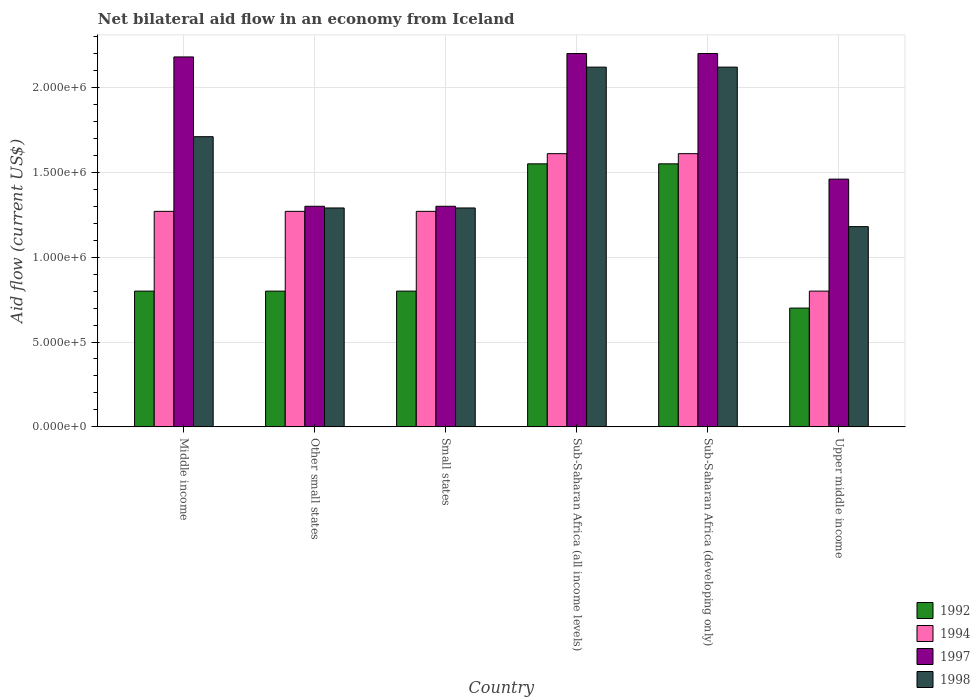How many groups of bars are there?
Provide a succinct answer. 6. How many bars are there on the 3rd tick from the left?
Keep it short and to the point. 4. How many bars are there on the 6th tick from the right?
Provide a succinct answer. 4. What is the label of the 1st group of bars from the left?
Ensure brevity in your answer.  Middle income. What is the net bilateral aid flow in 1992 in Other small states?
Give a very brief answer. 8.00e+05. Across all countries, what is the maximum net bilateral aid flow in 1994?
Your answer should be very brief. 1.61e+06. Across all countries, what is the minimum net bilateral aid flow in 1992?
Your answer should be compact. 7.00e+05. In which country was the net bilateral aid flow in 1997 maximum?
Provide a succinct answer. Sub-Saharan Africa (all income levels). In which country was the net bilateral aid flow in 1998 minimum?
Keep it short and to the point. Upper middle income. What is the total net bilateral aid flow in 1997 in the graph?
Your answer should be compact. 1.06e+07. What is the difference between the net bilateral aid flow in 1994 in Middle income and that in Upper middle income?
Provide a succinct answer. 4.70e+05. What is the difference between the net bilateral aid flow in 1994 in Sub-Saharan Africa (developing only) and the net bilateral aid flow in 1997 in Middle income?
Make the answer very short. -5.70e+05. What is the average net bilateral aid flow in 1998 per country?
Your response must be concise. 1.62e+06. What is the ratio of the net bilateral aid flow in 1998 in Middle income to that in Small states?
Offer a terse response. 1.33. Is the net bilateral aid flow in 1992 in Middle income less than that in Small states?
Keep it short and to the point. No. Is the difference between the net bilateral aid flow in 1994 in Other small states and Upper middle income greater than the difference between the net bilateral aid flow in 1998 in Other small states and Upper middle income?
Provide a short and direct response. Yes. In how many countries, is the net bilateral aid flow in 1992 greater than the average net bilateral aid flow in 1992 taken over all countries?
Give a very brief answer. 2. Is the sum of the net bilateral aid flow in 1992 in Small states and Upper middle income greater than the maximum net bilateral aid flow in 1998 across all countries?
Ensure brevity in your answer.  No. What does the 4th bar from the left in Sub-Saharan Africa (developing only) represents?
Make the answer very short. 1998. Is it the case that in every country, the sum of the net bilateral aid flow in 1992 and net bilateral aid flow in 1998 is greater than the net bilateral aid flow in 1997?
Your answer should be compact. Yes. How many legend labels are there?
Keep it short and to the point. 4. How are the legend labels stacked?
Provide a succinct answer. Vertical. What is the title of the graph?
Your answer should be compact. Net bilateral aid flow in an economy from Iceland. Does "1979" appear as one of the legend labels in the graph?
Make the answer very short. No. What is the label or title of the X-axis?
Provide a succinct answer. Country. What is the label or title of the Y-axis?
Provide a succinct answer. Aid flow (current US$). What is the Aid flow (current US$) in 1994 in Middle income?
Provide a short and direct response. 1.27e+06. What is the Aid flow (current US$) in 1997 in Middle income?
Your response must be concise. 2.18e+06. What is the Aid flow (current US$) of 1998 in Middle income?
Provide a succinct answer. 1.71e+06. What is the Aid flow (current US$) in 1994 in Other small states?
Offer a very short reply. 1.27e+06. What is the Aid flow (current US$) of 1997 in Other small states?
Provide a succinct answer. 1.30e+06. What is the Aid flow (current US$) in 1998 in Other small states?
Keep it short and to the point. 1.29e+06. What is the Aid flow (current US$) in 1994 in Small states?
Ensure brevity in your answer.  1.27e+06. What is the Aid flow (current US$) of 1997 in Small states?
Give a very brief answer. 1.30e+06. What is the Aid flow (current US$) of 1998 in Small states?
Give a very brief answer. 1.29e+06. What is the Aid flow (current US$) in 1992 in Sub-Saharan Africa (all income levels)?
Offer a very short reply. 1.55e+06. What is the Aid flow (current US$) in 1994 in Sub-Saharan Africa (all income levels)?
Provide a succinct answer. 1.61e+06. What is the Aid flow (current US$) of 1997 in Sub-Saharan Africa (all income levels)?
Your response must be concise. 2.20e+06. What is the Aid flow (current US$) of 1998 in Sub-Saharan Africa (all income levels)?
Offer a very short reply. 2.12e+06. What is the Aid flow (current US$) in 1992 in Sub-Saharan Africa (developing only)?
Ensure brevity in your answer.  1.55e+06. What is the Aid flow (current US$) in 1994 in Sub-Saharan Africa (developing only)?
Offer a very short reply. 1.61e+06. What is the Aid flow (current US$) of 1997 in Sub-Saharan Africa (developing only)?
Offer a terse response. 2.20e+06. What is the Aid flow (current US$) of 1998 in Sub-Saharan Africa (developing only)?
Make the answer very short. 2.12e+06. What is the Aid flow (current US$) in 1992 in Upper middle income?
Offer a terse response. 7.00e+05. What is the Aid flow (current US$) of 1994 in Upper middle income?
Make the answer very short. 8.00e+05. What is the Aid flow (current US$) in 1997 in Upper middle income?
Your response must be concise. 1.46e+06. What is the Aid flow (current US$) in 1998 in Upper middle income?
Provide a succinct answer. 1.18e+06. Across all countries, what is the maximum Aid flow (current US$) of 1992?
Offer a terse response. 1.55e+06. Across all countries, what is the maximum Aid flow (current US$) in 1994?
Make the answer very short. 1.61e+06. Across all countries, what is the maximum Aid flow (current US$) of 1997?
Make the answer very short. 2.20e+06. Across all countries, what is the maximum Aid flow (current US$) of 1998?
Make the answer very short. 2.12e+06. Across all countries, what is the minimum Aid flow (current US$) of 1997?
Your response must be concise. 1.30e+06. Across all countries, what is the minimum Aid flow (current US$) in 1998?
Make the answer very short. 1.18e+06. What is the total Aid flow (current US$) in 1992 in the graph?
Give a very brief answer. 6.20e+06. What is the total Aid flow (current US$) in 1994 in the graph?
Ensure brevity in your answer.  7.83e+06. What is the total Aid flow (current US$) in 1997 in the graph?
Your answer should be compact. 1.06e+07. What is the total Aid flow (current US$) in 1998 in the graph?
Provide a short and direct response. 9.71e+06. What is the difference between the Aid flow (current US$) of 1992 in Middle income and that in Other small states?
Give a very brief answer. 0. What is the difference between the Aid flow (current US$) of 1994 in Middle income and that in Other small states?
Your answer should be very brief. 0. What is the difference between the Aid flow (current US$) in 1997 in Middle income and that in Other small states?
Your response must be concise. 8.80e+05. What is the difference between the Aid flow (current US$) in 1992 in Middle income and that in Small states?
Offer a very short reply. 0. What is the difference between the Aid flow (current US$) of 1994 in Middle income and that in Small states?
Keep it short and to the point. 0. What is the difference between the Aid flow (current US$) in 1997 in Middle income and that in Small states?
Provide a short and direct response. 8.80e+05. What is the difference between the Aid flow (current US$) in 1992 in Middle income and that in Sub-Saharan Africa (all income levels)?
Keep it short and to the point. -7.50e+05. What is the difference between the Aid flow (current US$) of 1994 in Middle income and that in Sub-Saharan Africa (all income levels)?
Offer a very short reply. -3.40e+05. What is the difference between the Aid flow (current US$) of 1997 in Middle income and that in Sub-Saharan Africa (all income levels)?
Your answer should be compact. -2.00e+04. What is the difference between the Aid flow (current US$) in 1998 in Middle income and that in Sub-Saharan Africa (all income levels)?
Your response must be concise. -4.10e+05. What is the difference between the Aid flow (current US$) in 1992 in Middle income and that in Sub-Saharan Africa (developing only)?
Provide a succinct answer. -7.50e+05. What is the difference between the Aid flow (current US$) in 1994 in Middle income and that in Sub-Saharan Africa (developing only)?
Offer a terse response. -3.40e+05. What is the difference between the Aid flow (current US$) in 1998 in Middle income and that in Sub-Saharan Africa (developing only)?
Your response must be concise. -4.10e+05. What is the difference between the Aid flow (current US$) of 1994 in Middle income and that in Upper middle income?
Ensure brevity in your answer.  4.70e+05. What is the difference between the Aid flow (current US$) of 1997 in Middle income and that in Upper middle income?
Provide a short and direct response. 7.20e+05. What is the difference between the Aid flow (current US$) of 1998 in Middle income and that in Upper middle income?
Offer a terse response. 5.30e+05. What is the difference between the Aid flow (current US$) of 1992 in Other small states and that in Small states?
Offer a terse response. 0. What is the difference between the Aid flow (current US$) in 1997 in Other small states and that in Small states?
Ensure brevity in your answer.  0. What is the difference between the Aid flow (current US$) in 1992 in Other small states and that in Sub-Saharan Africa (all income levels)?
Provide a succinct answer. -7.50e+05. What is the difference between the Aid flow (current US$) of 1994 in Other small states and that in Sub-Saharan Africa (all income levels)?
Offer a terse response. -3.40e+05. What is the difference between the Aid flow (current US$) of 1997 in Other small states and that in Sub-Saharan Africa (all income levels)?
Your answer should be compact. -9.00e+05. What is the difference between the Aid flow (current US$) of 1998 in Other small states and that in Sub-Saharan Africa (all income levels)?
Provide a succinct answer. -8.30e+05. What is the difference between the Aid flow (current US$) in 1992 in Other small states and that in Sub-Saharan Africa (developing only)?
Keep it short and to the point. -7.50e+05. What is the difference between the Aid flow (current US$) of 1997 in Other small states and that in Sub-Saharan Africa (developing only)?
Offer a very short reply. -9.00e+05. What is the difference between the Aid flow (current US$) in 1998 in Other small states and that in Sub-Saharan Africa (developing only)?
Ensure brevity in your answer.  -8.30e+05. What is the difference between the Aid flow (current US$) in 1992 in Other small states and that in Upper middle income?
Ensure brevity in your answer.  1.00e+05. What is the difference between the Aid flow (current US$) of 1994 in Other small states and that in Upper middle income?
Your answer should be very brief. 4.70e+05. What is the difference between the Aid flow (current US$) of 1998 in Other small states and that in Upper middle income?
Offer a terse response. 1.10e+05. What is the difference between the Aid flow (current US$) in 1992 in Small states and that in Sub-Saharan Africa (all income levels)?
Ensure brevity in your answer.  -7.50e+05. What is the difference between the Aid flow (current US$) of 1997 in Small states and that in Sub-Saharan Africa (all income levels)?
Your answer should be very brief. -9.00e+05. What is the difference between the Aid flow (current US$) in 1998 in Small states and that in Sub-Saharan Africa (all income levels)?
Provide a short and direct response. -8.30e+05. What is the difference between the Aid flow (current US$) in 1992 in Small states and that in Sub-Saharan Africa (developing only)?
Offer a very short reply. -7.50e+05. What is the difference between the Aid flow (current US$) of 1994 in Small states and that in Sub-Saharan Africa (developing only)?
Offer a terse response. -3.40e+05. What is the difference between the Aid flow (current US$) in 1997 in Small states and that in Sub-Saharan Africa (developing only)?
Make the answer very short. -9.00e+05. What is the difference between the Aid flow (current US$) of 1998 in Small states and that in Sub-Saharan Africa (developing only)?
Offer a terse response. -8.30e+05. What is the difference between the Aid flow (current US$) of 1992 in Small states and that in Upper middle income?
Your answer should be compact. 1.00e+05. What is the difference between the Aid flow (current US$) of 1992 in Sub-Saharan Africa (all income levels) and that in Sub-Saharan Africa (developing only)?
Offer a very short reply. 0. What is the difference between the Aid flow (current US$) in 1992 in Sub-Saharan Africa (all income levels) and that in Upper middle income?
Ensure brevity in your answer.  8.50e+05. What is the difference between the Aid flow (current US$) of 1994 in Sub-Saharan Africa (all income levels) and that in Upper middle income?
Ensure brevity in your answer.  8.10e+05. What is the difference between the Aid flow (current US$) in 1997 in Sub-Saharan Africa (all income levels) and that in Upper middle income?
Provide a succinct answer. 7.40e+05. What is the difference between the Aid flow (current US$) in 1998 in Sub-Saharan Africa (all income levels) and that in Upper middle income?
Offer a very short reply. 9.40e+05. What is the difference between the Aid flow (current US$) in 1992 in Sub-Saharan Africa (developing only) and that in Upper middle income?
Provide a short and direct response. 8.50e+05. What is the difference between the Aid flow (current US$) of 1994 in Sub-Saharan Africa (developing only) and that in Upper middle income?
Keep it short and to the point. 8.10e+05. What is the difference between the Aid flow (current US$) in 1997 in Sub-Saharan Africa (developing only) and that in Upper middle income?
Give a very brief answer. 7.40e+05. What is the difference between the Aid flow (current US$) in 1998 in Sub-Saharan Africa (developing only) and that in Upper middle income?
Your answer should be compact. 9.40e+05. What is the difference between the Aid flow (current US$) in 1992 in Middle income and the Aid flow (current US$) in 1994 in Other small states?
Your answer should be compact. -4.70e+05. What is the difference between the Aid flow (current US$) of 1992 in Middle income and the Aid flow (current US$) of 1997 in Other small states?
Your answer should be very brief. -5.00e+05. What is the difference between the Aid flow (current US$) of 1992 in Middle income and the Aid flow (current US$) of 1998 in Other small states?
Give a very brief answer. -4.90e+05. What is the difference between the Aid flow (current US$) of 1994 in Middle income and the Aid flow (current US$) of 1997 in Other small states?
Your answer should be compact. -3.00e+04. What is the difference between the Aid flow (current US$) of 1997 in Middle income and the Aid flow (current US$) of 1998 in Other small states?
Ensure brevity in your answer.  8.90e+05. What is the difference between the Aid flow (current US$) of 1992 in Middle income and the Aid flow (current US$) of 1994 in Small states?
Your answer should be very brief. -4.70e+05. What is the difference between the Aid flow (current US$) in 1992 in Middle income and the Aid flow (current US$) in 1997 in Small states?
Your answer should be compact. -5.00e+05. What is the difference between the Aid flow (current US$) in 1992 in Middle income and the Aid flow (current US$) in 1998 in Small states?
Your answer should be compact. -4.90e+05. What is the difference between the Aid flow (current US$) of 1994 in Middle income and the Aid flow (current US$) of 1997 in Small states?
Ensure brevity in your answer.  -3.00e+04. What is the difference between the Aid flow (current US$) of 1997 in Middle income and the Aid flow (current US$) of 1998 in Small states?
Your answer should be very brief. 8.90e+05. What is the difference between the Aid flow (current US$) in 1992 in Middle income and the Aid flow (current US$) in 1994 in Sub-Saharan Africa (all income levels)?
Your answer should be compact. -8.10e+05. What is the difference between the Aid flow (current US$) of 1992 in Middle income and the Aid flow (current US$) of 1997 in Sub-Saharan Africa (all income levels)?
Offer a very short reply. -1.40e+06. What is the difference between the Aid flow (current US$) in 1992 in Middle income and the Aid flow (current US$) in 1998 in Sub-Saharan Africa (all income levels)?
Keep it short and to the point. -1.32e+06. What is the difference between the Aid flow (current US$) of 1994 in Middle income and the Aid flow (current US$) of 1997 in Sub-Saharan Africa (all income levels)?
Your response must be concise. -9.30e+05. What is the difference between the Aid flow (current US$) of 1994 in Middle income and the Aid flow (current US$) of 1998 in Sub-Saharan Africa (all income levels)?
Give a very brief answer. -8.50e+05. What is the difference between the Aid flow (current US$) in 1992 in Middle income and the Aid flow (current US$) in 1994 in Sub-Saharan Africa (developing only)?
Your answer should be very brief. -8.10e+05. What is the difference between the Aid flow (current US$) in 1992 in Middle income and the Aid flow (current US$) in 1997 in Sub-Saharan Africa (developing only)?
Your response must be concise. -1.40e+06. What is the difference between the Aid flow (current US$) in 1992 in Middle income and the Aid flow (current US$) in 1998 in Sub-Saharan Africa (developing only)?
Offer a very short reply. -1.32e+06. What is the difference between the Aid flow (current US$) in 1994 in Middle income and the Aid flow (current US$) in 1997 in Sub-Saharan Africa (developing only)?
Keep it short and to the point. -9.30e+05. What is the difference between the Aid flow (current US$) of 1994 in Middle income and the Aid flow (current US$) of 1998 in Sub-Saharan Africa (developing only)?
Offer a terse response. -8.50e+05. What is the difference between the Aid flow (current US$) in 1992 in Middle income and the Aid flow (current US$) in 1997 in Upper middle income?
Ensure brevity in your answer.  -6.60e+05. What is the difference between the Aid flow (current US$) of 1992 in Middle income and the Aid flow (current US$) of 1998 in Upper middle income?
Your response must be concise. -3.80e+05. What is the difference between the Aid flow (current US$) in 1994 in Middle income and the Aid flow (current US$) in 1997 in Upper middle income?
Your response must be concise. -1.90e+05. What is the difference between the Aid flow (current US$) in 1992 in Other small states and the Aid flow (current US$) in 1994 in Small states?
Make the answer very short. -4.70e+05. What is the difference between the Aid flow (current US$) of 1992 in Other small states and the Aid flow (current US$) of 1997 in Small states?
Offer a terse response. -5.00e+05. What is the difference between the Aid flow (current US$) in 1992 in Other small states and the Aid flow (current US$) in 1998 in Small states?
Give a very brief answer. -4.90e+05. What is the difference between the Aid flow (current US$) of 1997 in Other small states and the Aid flow (current US$) of 1998 in Small states?
Your answer should be compact. 10000. What is the difference between the Aid flow (current US$) of 1992 in Other small states and the Aid flow (current US$) of 1994 in Sub-Saharan Africa (all income levels)?
Your response must be concise. -8.10e+05. What is the difference between the Aid flow (current US$) of 1992 in Other small states and the Aid flow (current US$) of 1997 in Sub-Saharan Africa (all income levels)?
Your answer should be compact. -1.40e+06. What is the difference between the Aid flow (current US$) of 1992 in Other small states and the Aid flow (current US$) of 1998 in Sub-Saharan Africa (all income levels)?
Offer a terse response. -1.32e+06. What is the difference between the Aid flow (current US$) of 1994 in Other small states and the Aid flow (current US$) of 1997 in Sub-Saharan Africa (all income levels)?
Offer a very short reply. -9.30e+05. What is the difference between the Aid flow (current US$) in 1994 in Other small states and the Aid flow (current US$) in 1998 in Sub-Saharan Africa (all income levels)?
Offer a terse response. -8.50e+05. What is the difference between the Aid flow (current US$) of 1997 in Other small states and the Aid flow (current US$) of 1998 in Sub-Saharan Africa (all income levels)?
Provide a succinct answer. -8.20e+05. What is the difference between the Aid flow (current US$) of 1992 in Other small states and the Aid flow (current US$) of 1994 in Sub-Saharan Africa (developing only)?
Give a very brief answer. -8.10e+05. What is the difference between the Aid flow (current US$) in 1992 in Other small states and the Aid flow (current US$) in 1997 in Sub-Saharan Africa (developing only)?
Your response must be concise. -1.40e+06. What is the difference between the Aid flow (current US$) in 1992 in Other small states and the Aid flow (current US$) in 1998 in Sub-Saharan Africa (developing only)?
Keep it short and to the point. -1.32e+06. What is the difference between the Aid flow (current US$) in 1994 in Other small states and the Aid flow (current US$) in 1997 in Sub-Saharan Africa (developing only)?
Your answer should be compact. -9.30e+05. What is the difference between the Aid flow (current US$) of 1994 in Other small states and the Aid flow (current US$) of 1998 in Sub-Saharan Africa (developing only)?
Provide a short and direct response. -8.50e+05. What is the difference between the Aid flow (current US$) of 1997 in Other small states and the Aid flow (current US$) of 1998 in Sub-Saharan Africa (developing only)?
Make the answer very short. -8.20e+05. What is the difference between the Aid flow (current US$) of 1992 in Other small states and the Aid flow (current US$) of 1994 in Upper middle income?
Offer a very short reply. 0. What is the difference between the Aid flow (current US$) in 1992 in Other small states and the Aid flow (current US$) in 1997 in Upper middle income?
Provide a short and direct response. -6.60e+05. What is the difference between the Aid flow (current US$) in 1992 in Other small states and the Aid flow (current US$) in 1998 in Upper middle income?
Give a very brief answer. -3.80e+05. What is the difference between the Aid flow (current US$) of 1994 in Other small states and the Aid flow (current US$) of 1998 in Upper middle income?
Provide a succinct answer. 9.00e+04. What is the difference between the Aid flow (current US$) of 1997 in Other small states and the Aid flow (current US$) of 1998 in Upper middle income?
Keep it short and to the point. 1.20e+05. What is the difference between the Aid flow (current US$) of 1992 in Small states and the Aid flow (current US$) of 1994 in Sub-Saharan Africa (all income levels)?
Keep it short and to the point. -8.10e+05. What is the difference between the Aid flow (current US$) of 1992 in Small states and the Aid flow (current US$) of 1997 in Sub-Saharan Africa (all income levels)?
Provide a succinct answer. -1.40e+06. What is the difference between the Aid flow (current US$) in 1992 in Small states and the Aid flow (current US$) in 1998 in Sub-Saharan Africa (all income levels)?
Your answer should be compact. -1.32e+06. What is the difference between the Aid flow (current US$) in 1994 in Small states and the Aid flow (current US$) in 1997 in Sub-Saharan Africa (all income levels)?
Make the answer very short. -9.30e+05. What is the difference between the Aid flow (current US$) of 1994 in Small states and the Aid flow (current US$) of 1998 in Sub-Saharan Africa (all income levels)?
Your answer should be compact. -8.50e+05. What is the difference between the Aid flow (current US$) of 1997 in Small states and the Aid flow (current US$) of 1998 in Sub-Saharan Africa (all income levels)?
Offer a very short reply. -8.20e+05. What is the difference between the Aid flow (current US$) in 1992 in Small states and the Aid flow (current US$) in 1994 in Sub-Saharan Africa (developing only)?
Your answer should be very brief. -8.10e+05. What is the difference between the Aid flow (current US$) in 1992 in Small states and the Aid flow (current US$) in 1997 in Sub-Saharan Africa (developing only)?
Make the answer very short. -1.40e+06. What is the difference between the Aid flow (current US$) in 1992 in Small states and the Aid flow (current US$) in 1998 in Sub-Saharan Africa (developing only)?
Your answer should be very brief. -1.32e+06. What is the difference between the Aid flow (current US$) of 1994 in Small states and the Aid flow (current US$) of 1997 in Sub-Saharan Africa (developing only)?
Offer a terse response. -9.30e+05. What is the difference between the Aid flow (current US$) of 1994 in Small states and the Aid flow (current US$) of 1998 in Sub-Saharan Africa (developing only)?
Offer a very short reply. -8.50e+05. What is the difference between the Aid flow (current US$) in 1997 in Small states and the Aid flow (current US$) in 1998 in Sub-Saharan Africa (developing only)?
Give a very brief answer. -8.20e+05. What is the difference between the Aid flow (current US$) of 1992 in Small states and the Aid flow (current US$) of 1994 in Upper middle income?
Provide a succinct answer. 0. What is the difference between the Aid flow (current US$) of 1992 in Small states and the Aid flow (current US$) of 1997 in Upper middle income?
Ensure brevity in your answer.  -6.60e+05. What is the difference between the Aid flow (current US$) of 1992 in Small states and the Aid flow (current US$) of 1998 in Upper middle income?
Make the answer very short. -3.80e+05. What is the difference between the Aid flow (current US$) of 1994 in Small states and the Aid flow (current US$) of 1997 in Upper middle income?
Your answer should be very brief. -1.90e+05. What is the difference between the Aid flow (current US$) of 1994 in Small states and the Aid flow (current US$) of 1998 in Upper middle income?
Keep it short and to the point. 9.00e+04. What is the difference between the Aid flow (current US$) in 1992 in Sub-Saharan Africa (all income levels) and the Aid flow (current US$) in 1997 in Sub-Saharan Africa (developing only)?
Your response must be concise. -6.50e+05. What is the difference between the Aid flow (current US$) in 1992 in Sub-Saharan Africa (all income levels) and the Aid flow (current US$) in 1998 in Sub-Saharan Africa (developing only)?
Make the answer very short. -5.70e+05. What is the difference between the Aid flow (current US$) of 1994 in Sub-Saharan Africa (all income levels) and the Aid flow (current US$) of 1997 in Sub-Saharan Africa (developing only)?
Provide a short and direct response. -5.90e+05. What is the difference between the Aid flow (current US$) of 1994 in Sub-Saharan Africa (all income levels) and the Aid flow (current US$) of 1998 in Sub-Saharan Africa (developing only)?
Your answer should be very brief. -5.10e+05. What is the difference between the Aid flow (current US$) in 1997 in Sub-Saharan Africa (all income levels) and the Aid flow (current US$) in 1998 in Sub-Saharan Africa (developing only)?
Provide a succinct answer. 8.00e+04. What is the difference between the Aid flow (current US$) in 1992 in Sub-Saharan Africa (all income levels) and the Aid flow (current US$) in 1994 in Upper middle income?
Provide a short and direct response. 7.50e+05. What is the difference between the Aid flow (current US$) in 1997 in Sub-Saharan Africa (all income levels) and the Aid flow (current US$) in 1998 in Upper middle income?
Provide a short and direct response. 1.02e+06. What is the difference between the Aid flow (current US$) of 1992 in Sub-Saharan Africa (developing only) and the Aid flow (current US$) of 1994 in Upper middle income?
Ensure brevity in your answer.  7.50e+05. What is the difference between the Aid flow (current US$) in 1992 in Sub-Saharan Africa (developing only) and the Aid flow (current US$) in 1997 in Upper middle income?
Give a very brief answer. 9.00e+04. What is the difference between the Aid flow (current US$) in 1994 in Sub-Saharan Africa (developing only) and the Aid flow (current US$) in 1997 in Upper middle income?
Your answer should be very brief. 1.50e+05. What is the difference between the Aid flow (current US$) in 1997 in Sub-Saharan Africa (developing only) and the Aid flow (current US$) in 1998 in Upper middle income?
Keep it short and to the point. 1.02e+06. What is the average Aid flow (current US$) in 1992 per country?
Keep it short and to the point. 1.03e+06. What is the average Aid flow (current US$) of 1994 per country?
Offer a very short reply. 1.30e+06. What is the average Aid flow (current US$) in 1997 per country?
Ensure brevity in your answer.  1.77e+06. What is the average Aid flow (current US$) of 1998 per country?
Keep it short and to the point. 1.62e+06. What is the difference between the Aid flow (current US$) of 1992 and Aid flow (current US$) of 1994 in Middle income?
Give a very brief answer. -4.70e+05. What is the difference between the Aid flow (current US$) in 1992 and Aid flow (current US$) in 1997 in Middle income?
Make the answer very short. -1.38e+06. What is the difference between the Aid flow (current US$) in 1992 and Aid flow (current US$) in 1998 in Middle income?
Give a very brief answer. -9.10e+05. What is the difference between the Aid flow (current US$) of 1994 and Aid flow (current US$) of 1997 in Middle income?
Provide a succinct answer. -9.10e+05. What is the difference between the Aid flow (current US$) of 1994 and Aid flow (current US$) of 1998 in Middle income?
Ensure brevity in your answer.  -4.40e+05. What is the difference between the Aid flow (current US$) of 1992 and Aid flow (current US$) of 1994 in Other small states?
Offer a terse response. -4.70e+05. What is the difference between the Aid flow (current US$) of 1992 and Aid flow (current US$) of 1997 in Other small states?
Offer a terse response. -5.00e+05. What is the difference between the Aid flow (current US$) in 1992 and Aid flow (current US$) in 1998 in Other small states?
Ensure brevity in your answer.  -4.90e+05. What is the difference between the Aid flow (current US$) in 1994 and Aid flow (current US$) in 1997 in Other small states?
Offer a terse response. -3.00e+04. What is the difference between the Aid flow (current US$) of 1992 and Aid flow (current US$) of 1994 in Small states?
Offer a very short reply. -4.70e+05. What is the difference between the Aid flow (current US$) of 1992 and Aid flow (current US$) of 1997 in Small states?
Keep it short and to the point. -5.00e+05. What is the difference between the Aid flow (current US$) of 1992 and Aid flow (current US$) of 1998 in Small states?
Make the answer very short. -4.90e+05. What is the difference between the Aid flow (current US$) of 1994 and Aid flow (current US$) of 1997 in Small states?
Provide a succinct answer. -3.00e+04. What is the difference between the Aid flow (current US$) of 1994 and Aid flow (current US$) of 1998 in Small states?
Keep it short and to the point. -2.00e+04. What is the difference between the Aid flow (current US$) in 1997 and Aid flow (current US$) in 1998 in Small states?
Keep it short and to the point. 10000. What is the difference between the Aid flow (current US$) in 1992 and Aid flow (current US$) in 1997 in Sub-Saharan Africa (all income levels)?
Make the answer very short. -6.50e+05. What is the difference between the Aid flow (current US$) of 1992 and Aid flow (current US$) of 1998 in Sub-Saharan Africa (all income levels)?
Your answer should be very brief. -5.70e+05. What is the difference between the Aid flow (current US$) in 1994 and Aid flow (current US$) in 1997 in Sub-Saharan Africa (all income levels)?
Make the answer very short. -5.90e+05. What is the difference between the Aid flow (current US$) of 1994 and Aid flow (current US$) of 1998 in Sub-Saharan Africa (all income levels)?
Ensure brevity in your answer.  -5.10e+05. What is the difference between the Aid flow (current US$) of 1992 and Aid flow (current US$) of 1997 in Sub-Saharan Africa (developing only)?
Your response must be concise. -6.50e+05. What is the difference between the Aid flow (current US$) of 1992 and Aid flow (current US$) of 1998 in Sub-Saharan Africa (developing only)?
Give a very brief answer. -5.70e+05. What is the difference between the Aid flow (current US$) of 1994 and Aid flow (current US$) of 1997 in Sub-Saharan Africa (developing only)?
Keep it short and to the point. -5.90e+05. What is the difference between the Aid flow (current US$) in 1994 and Aid flow (current US$) in 1998 in Sub-Saharan Africa (developing only)?
Provide a short and direct response. -5.10e+05. What is the difference between the Aid flow (current US$) in 1997 and Aid flow (current US$) in 1998 in Sub-Saharan Africa (developing only)?
Make the answer very short. 8.00e+04. What is the difference between the Aid flow (current US$) in 1992 and Aid flow (current US$) in 1997 in Upper middle income?
Give a very brief answer. -7.60e+05. What is the difference between the Aid flow (current US$) in 1992 and Aid flow (current US$) in 1998 in Upper middle income?
Your response must be concise. -4.80e+05. What is the difference between the Aid flow (current US$) in 1994 and Aid flow (current US$) in 1997 in Upper middle income?
Provide a short and direct response. -6.60e+05. What is the difference between the Aid flow (current US$) of 1994 and Aid flow (current US$) of 1998 in Upper middle income?
Keep it short and to the point. -3.80e+05. What is the ratio of the Aid flow (current US$) in 1992 in Middle income to that in Other small states?
Your answer should be compact. 1. What is the ratio of the Aid flow (current US$) in 1997 in Middle income to that in Other small states?
Make the answer very short. 1.68. What is the ratio of the Aid flow (current US$) of 1998 in Middle income to that in Other small states?
Make the answer very short. 1.33. What is the ratio of the Aid flow (current US$) of 1992 in Middle income to that in Small states?
Make the answer very short. 1. What is the ratio of the Aid flow (current US$) of 1994 in Middle income to that in Small states?
Keep it short and to the point. 1. What is the ratio of the Aid flow (current US$) of 1997 in Middle income to that in Small states?
Your answer should be compact. 1.68. What is the ratio of the Aid flow (current US$) of 1998 in Middle income to that in Small states?
Keep it short and to the point. 1.33. What is the ratio of the Aid flow (current US$) of 1992 in Middle income to that in Sub-Saharan Africa (all income levels)?
Ensure brevity in your answer.  0.52. What is the ratio of the Aid flow (current US$) of 1994 in Middle income to that in Sub-Saharan Africa (all income levels)?
Give a very brief answer. 0.79. What is the ratio of the Aid flow (current US$) of 1997 in Middle income to that in Sub-Saharan Africa (all income levels)?
Give a very brief answer. 0.99. What is the ratio of the Aid flow (current US$) of 1998 in Middle income to that in Sub-Saharan Africa (all income levels)?
Provide a succinct answer. 0.81. What is the ratio of the Aid flow (current US$) of 1992 in Middle income to that in Sub-Saharan Africa (developing only)?
Keep it short and to the point. 0.52. What is the ratio of the Aid flow (current US$) in 1994 in Middle income to that in Sub-Saharan Africa (developing only)?
Your answer should be compact. 0.79. What is the ratio of the Aid flow (current US$) of 1997 in Middle income to that in Sub-Saharan Africa (developing only)?
Offer a terse response. 0.99. What is the ratio of the Aid flow (current US$) of 1998 in Middle income to that in Sub-Saharan Africa (developing only)?
Keep it short and to the point. 0.81. What is the ratio of the Aid flow (current US$) in 1992 in Middle income to that in Upper middle income?
Provide a succinct answer. 1.14. What is the ratio of the Aid flow (current US$) in 1994 in Middle income to that in Upper middle income?
Provide a short and direct response. 1.59. What is the ratio of the Aid flow (current US$) of 1997 in Middle income to that in Upper middle income?
Ensure brevity in your answer.  1.49. What is the ratio of the Aid flow (current US$) in 1998 in Middle income to that in Upper middle income?
Your answer should be very brief. 1.45. What is the ratio of the Aid flow (current US$) in 1992 in Other small states to that in Small states?
Provide a short and direct response. 1. What is the ratio of the Aid flow (current US$) of 1992 in Other small states to that in Sub-Saharan Africa (all income levels)?
Give a very brief answer. 0.52. What is the ratio of the Aid flow (current US$) of 1994 in Other small states to that in Sub-Saharan Africa (all income levels)?
Keep it short and to the point. 0.79. What is the ratio of the Aid flow (current US$) of 1997 in Other small states to that in Sub-Saharan Africa (all income levels)?
Your response must be concise. 0.59. What is the ratio of the Aid flow (current US$) of 1998 in Other small states to that in Sub-Saharan Africa (all income levels)?
Offer a very short reply. 0.61. What is the ratio of the Aid flow (current US$) in 1992 in Other small states to that in Sub-Saharan Africa (developing only)?
Your response must be concise. 0.52. What is the ratio of the Aid flow (current US$) of 1994 in Other small states to that in Sub-Saharan Africa (developing only)?
Your answer should be very brief. 0.79. What is the ratio of the Aid flow (current US$) of 1997 in Other small states to that in Sub-Saharan Africa (developing only)?
Ensure brevity in your answer.  0.59. What is the ratio of the Aid flow (current US$) in 1998 in Other small states to that in Sub-Saharan Africa (developing only)?
Make the answer very short. 0.61. What is the ratio of the Aid flow (current US$) in 1994 in Other small states to that in Upper middle income?
Give a very brief answer. 1.59. What is the ratio of the Aid flow (current US$) in 1997 in Other small states to that in Upper middle income?
Offer a terse response. 0.89. What is the ratio of the Aid flow (current US$) in 1998 in Other small states to that in Upper middle income?
Your answer should be compact. 1.09. What is the ratio of the Aid flow (current US$) of 1992 in Small states to that in Sub-Saharan Africa (all income levels)?
Make the answer very short. 0.52. What is the ratio of the Aid flow (current US$) in 1994 in Small states to that in Sub-Saharan Africa (all income levels)?
Make the answer very short. 0.79. What is the ratio of the Aid flow (current US$) in 1997 in Small states to that in Sub-Saharan Africa (all income levels)?
Keep it short and to the point. 0.59. What is the ratio of the Aid flow (current US$) in 1998 in Small states to that in Sub-Saharan Africa (all income levels)?
Provide a succinct answer. 0.61. What is the ratio of the Aid flow (current US$) of 1992 in Small states to that in Sub-Saharan Africa (developing only)?
Your answer should be compact. 0.52. What is the ratio of the Aid flow (current US$) of 1994 in Small states to that in Sub-Saharan Africa (developing only)?
Make the answer very short. 0.79. What is the ratio of the Aid flow (current US$) of 1997 in Small states to that in Sub-Saharan Africa (developing only)?
Give a very brief answer. 0.59. What is the ratio of the Aid flow (current US$) in 1998 in Small states to that in Sub-Saharan Africa (developing only)?
Your answer should be very brief. 0.61. What is the ratio of the Aid flow (current US$) of 1992 in Small states to that in Upper middle income?
Provide a short and direct response. 1.14. What is the ratio of the Aid flow (current US$) of 1994 in Small states to that in Upper middle income?
Your response must be concise. 1.59. What is the ratio of the Aid flow (current US$) in 1997 in Small states to that in Upper middle income?
Offer a terse response. 0.89. What is the ratio of the Aid flow (current US$) in 1998 in Small states to that in Upper middle income?
Your answer should be very brief. 1.09. What is the ratio of the Aid flow (current US$) in 1992 in Sub-Saharan Africa (all income levels) to that in Upper middle income?
Provide a succinct answer. 2.21. What is the ratio of the Aid flow (current US$) in 1994 in Sub-Saharan Africa (all income levels) to that in Upper middle income?
Your answer should be compact. 2.01. What is the ratio of the Aid flow (current US$) of 1997 in Sub-Saharan Africa (all income levels) to that in Upper middle income?
Make the answer very short. 1.51. What is the ratio of the Aid flow (current US$) of 1998 in Sub-Saharan Africa (all income levels) to that in Upper middle income?
Offer a very short reply. 1.8. What is the ratio of the Aid flow (current US$) of 1992 in Sub-Saharan Africa (developing only) to that in Upper middle income?
Provide a succinct answer. 2.21. What is the ratio of the Aid flow (current US$) in 1994 in Sub-Saharan Africa (developing only) to that in Upper middle income?
Ensure brevity in your answer.  2.01. What is the ratio of the Aid flow (current US$) of 1997 in Sub-Saharan Africa (developing only) to that in Upper middle income?
Your response must be concise. 1.51. What is the ratio of the Aid flow (current US$) in 1998 in Sub-Saharan Africa (developing only) to that in Upper middle income?
Provide a succinct answer. 1.8. What is the difference between the highest and the second highest Aid flow (current US$) of 1992?
Offer a terse response. 0. What is the difference between the highest and the second highest Aid flow (current US$) in 1997?
Offer a very short reply. 0. What is the difference between the highest and the second highest Aid flow (current US$) of 1998?
Offer a very short reply. 0. What is the difference between the highest and the lowest Aid flow (current US$) of 1992?
Your answer should be very brief. 8.50e+05. What is the difference between the highest and the lowest Aid flow (current US$) in 1994?
Your response must be concise. 8.10e+05. What is the difference between the highest and the lowest Aid flow (current US$) of 1998?
Make the answer very short. 9.40e+05. 